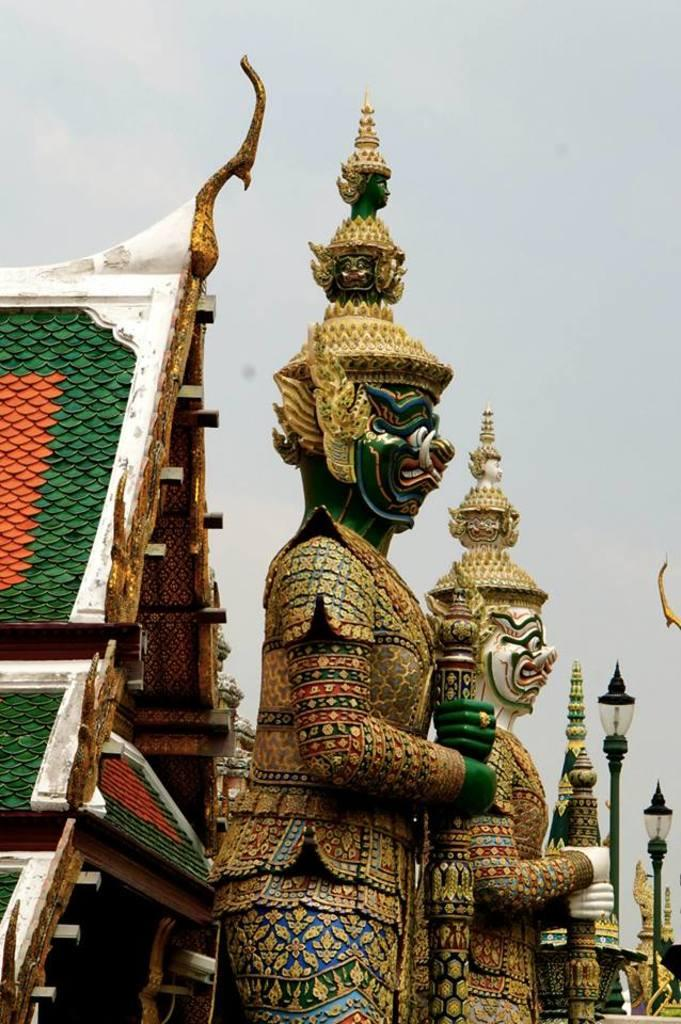What type of figures can be seen in the image? There are statues of gods in the image. What can be seen in the background of the image? There are houses and streetlights in the background of the image. What is visible in the sky in the image? The sky is visible in the background of the image. What type of shelf can be seen in the image? There is no shelf present in the image. What season is depicted in the image? The provided facts do not mention any specific season, so it cannot be determined from the image. 